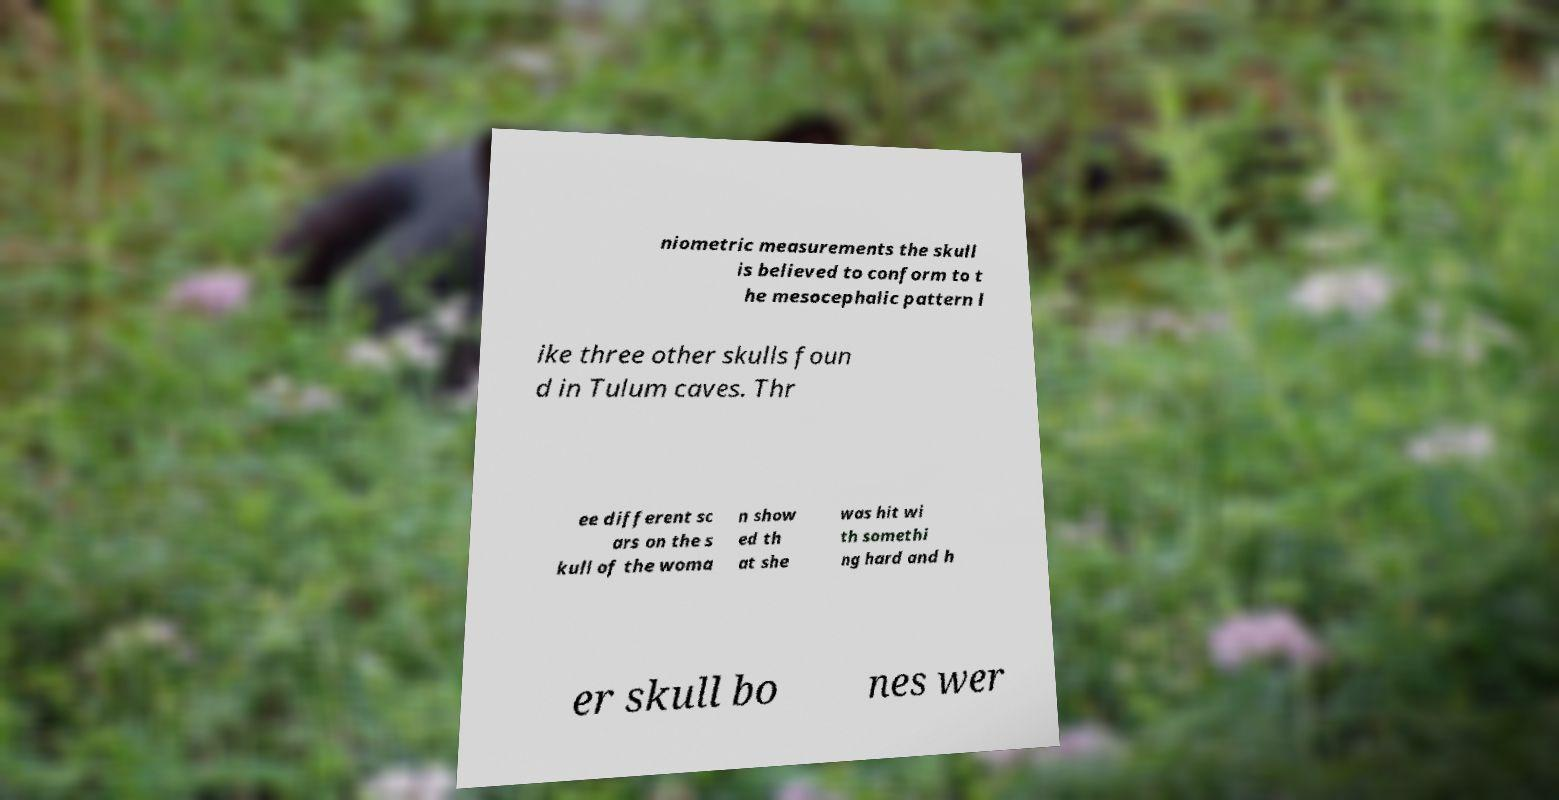What messages or text are displayed in this image? I need them in a readable, typed format. niometric measurements the skull is believed to conform to t he mesocephalic pattern l ike three other skulls foun d in Tulum caves. Thr ee different sc ars on the s kull of the woma n show ed th at she was hit wi th somethi ng hard and h er skull bo nes wer 